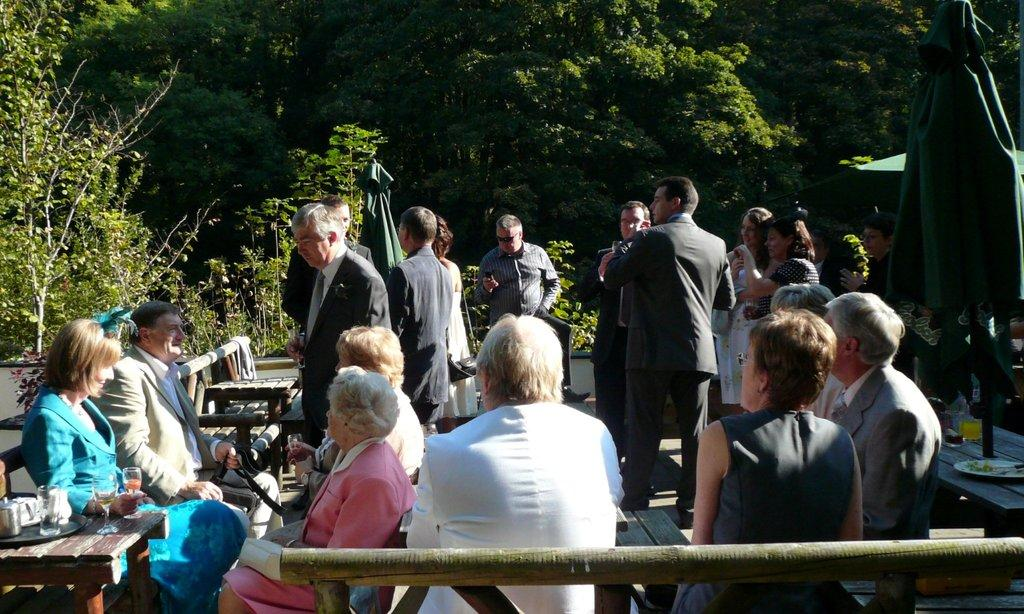How many people can be seen in the foreground of the picture? There are many people in the foreground of the picture. What type of furniture is present in the foreground of the picture? There are benches in the foreground of the picture. What items are used for eating and drinking in the foreground of the picture? There are plates and glasses in the foreground of the picture. What object is used for protection from the sun or rain in the foreground of the picture? There is an umbrella in the foreground of the picture. What type of food can be seen in the foreground of the picture? There are food items in the foreground of the picture. What other objects can be seen in the foreground of the picture? There are other objects in the foreground of the picture. What can be seen in the background of the picture? There are trees in the background of the picture. Can you see any ghosts causing trouble in the picture? There are no ghosts or any indication of trouble in the image. Is there an alarm going off in the picture? There is no alarm present in the image. 